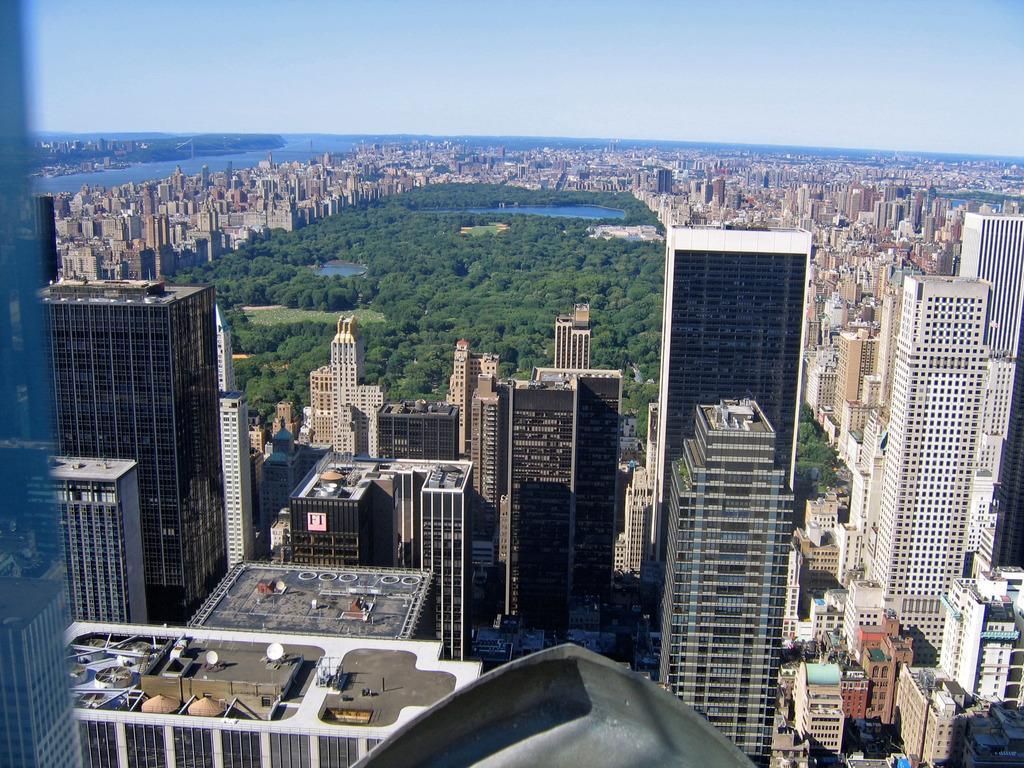How would you summarize this image in a sentence or two? In this image there are buildings, in the middle there are trees and pounds, in the background there is water surface and the sky. 